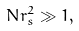Convert formula to latex. <formula><loc_0><loc_0><loc_500><loc_500>N r _ { s } ^ { 2 } \gg 1 ,</formula> 